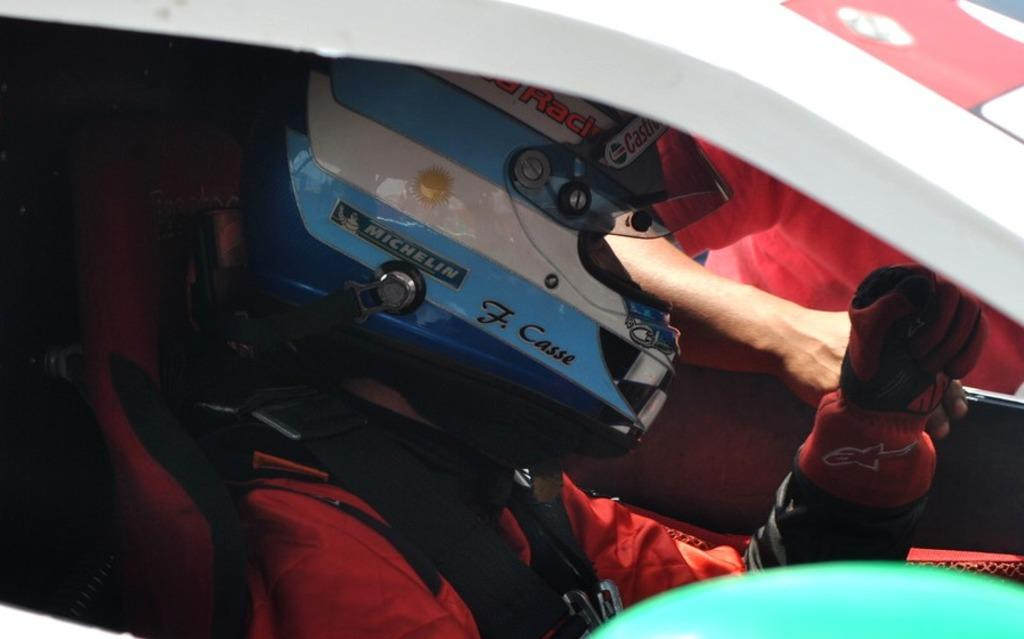What is the person in the image doing? The person is sitting inside a car in the image. What protective gear is the person wearing? The person is wearing a helmet. Can you describe the other person in the image? There is another person beside the car in the image. What type of wall can be seen behind the person in the image? There is no wall visible in the image; it features a person sitting inside a car and another person beside the car. What sport is being played in the image? There is no sport being played in the image; it features a person sitting inside a car and another person beside the car. 